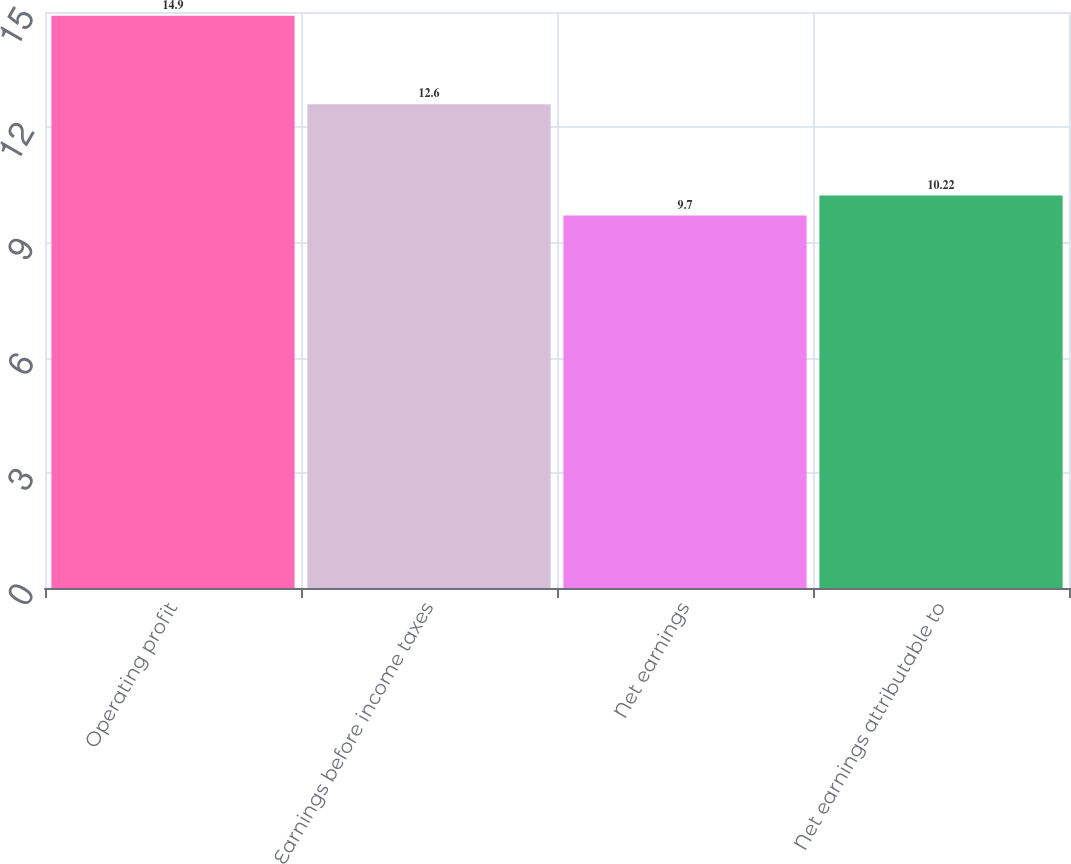<chart> <loc_0><loc_0><loc_500><loc_500><bar_chart><fcel>Operating profit<fcel>Earnings before income taxes<fcel>Net earnings<fcel>Net earnings attributable to<nl><fcel>14.9<fcel>12.6<fcel>9.7<fcel>10.22<nl></chart> 